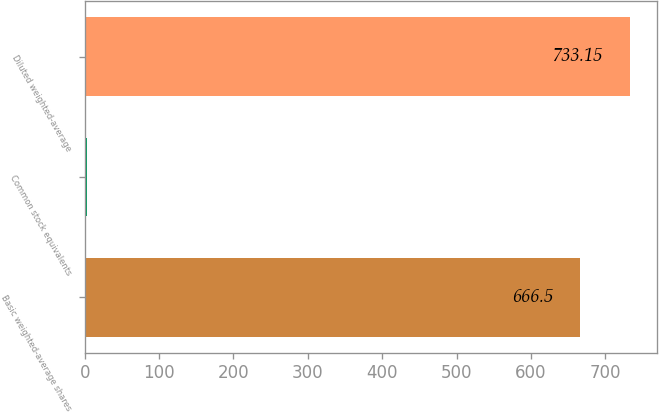Convert chart to OTSL. <chart><loc_0><loc_0><loc_500><loc_500><bar_chart><fcel>Basic weighted-average shares<fcel>Common stock equivalents<fcel>Diluted weighted-average<nl><fcel>666.5<fcel>2.4<fcel>733.15<nl></chart> 